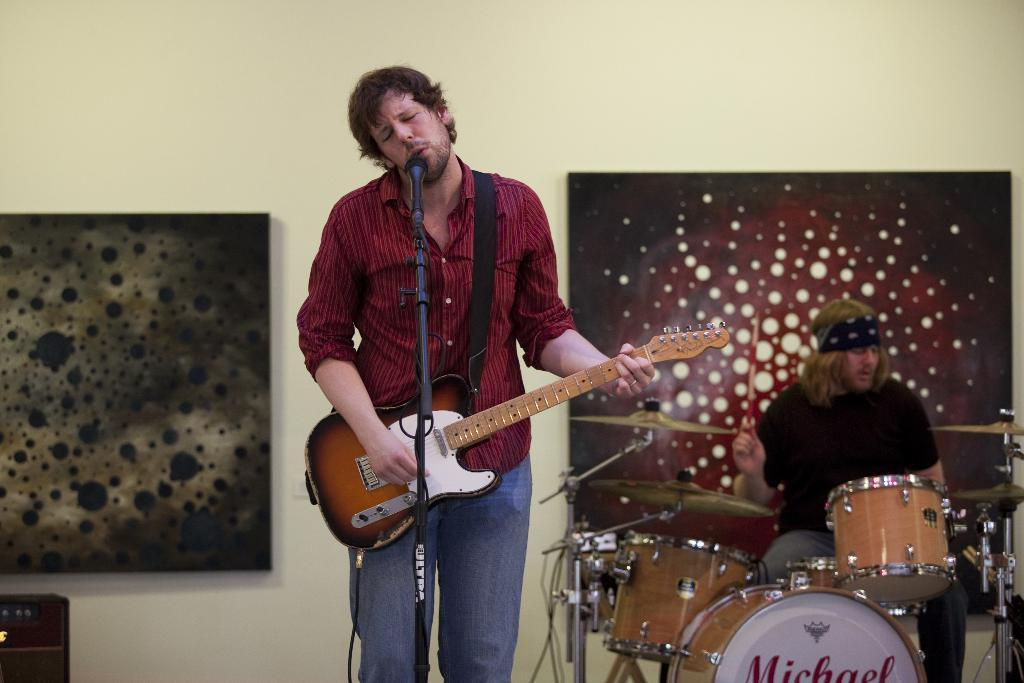What is the main activity being performed by the person in the image? The person in the image is playing guitar and singing. What equipment is the person using to amplify their voice? The person is standing in front of a microphone. What other musician is present in the image? There is a person playing drums in the image. Where is the drum player positioned in relation to the guitar player? The drum player is located to the left of the guitar player. What can be seen on the wall in the background? There are two frames present on the wall in the background. What type of toothbrush is the guitar player using in the image? There is no toothbrush present in the image; the person is playing guitar and singing. How does the guitar player get the attention of the audience in the image? The image does not show the guitar player interacting with an audience, so it cannot be determined how they get the attention of the audience. 